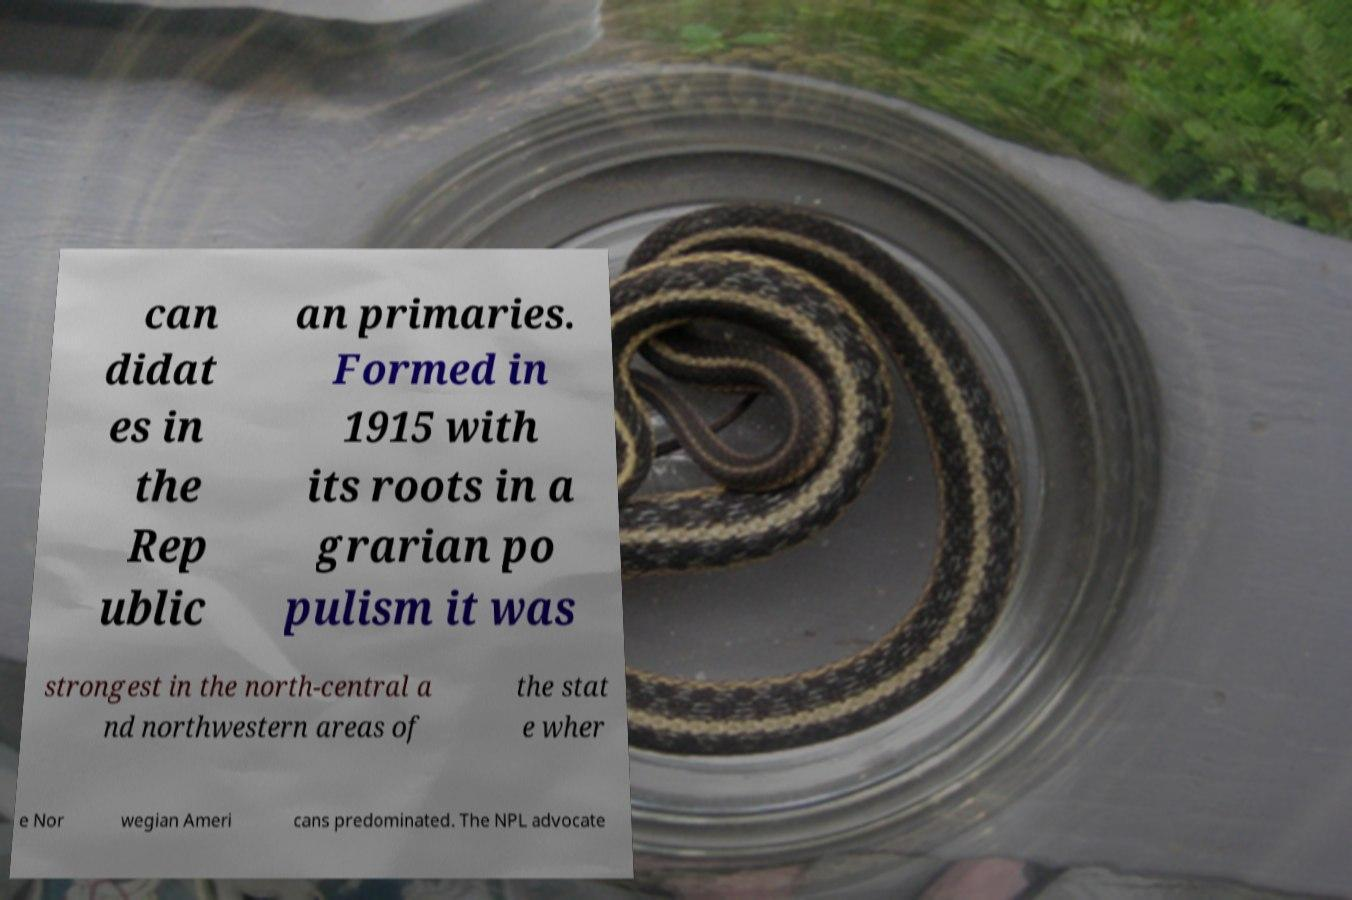Please read and relay the text visible in this image. What does it say? can didat es in the Rep ublic an primaries. Formed in 1915 with its roots in a grarian po pulism it was strongest in the north-central a nd northwestern areas of the stat e wher e Nor wegian Ameri cans predominated. The NPL advocate 